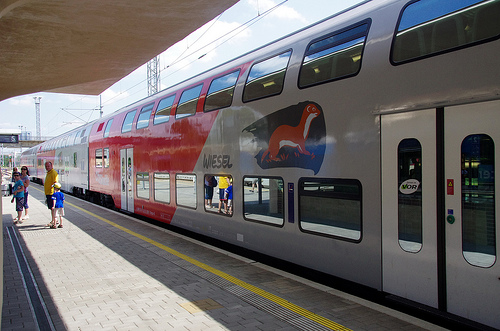Please provide a short description for this region: [0.48, 0.36, 0.65, 0.52]. The described region features a colorful mural of a weasel on the side of a train, capturing the vivid imagery portrayed there. 